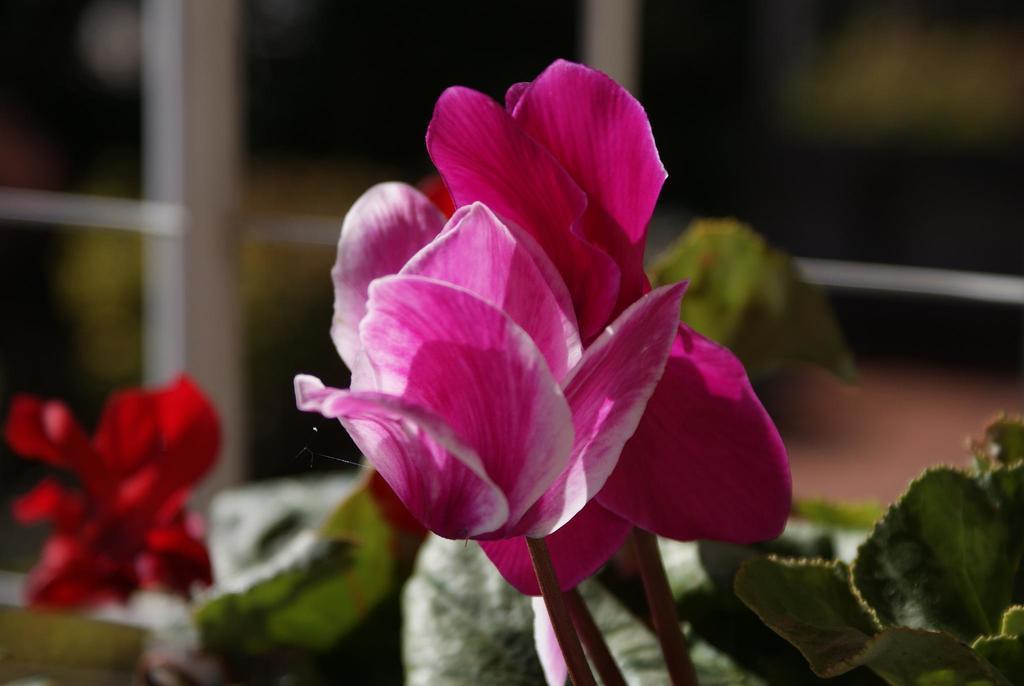Can you describe this image briefly? There is a pink flower to a plant and behind the plant there is another plant with red flower and the background is blurry. 